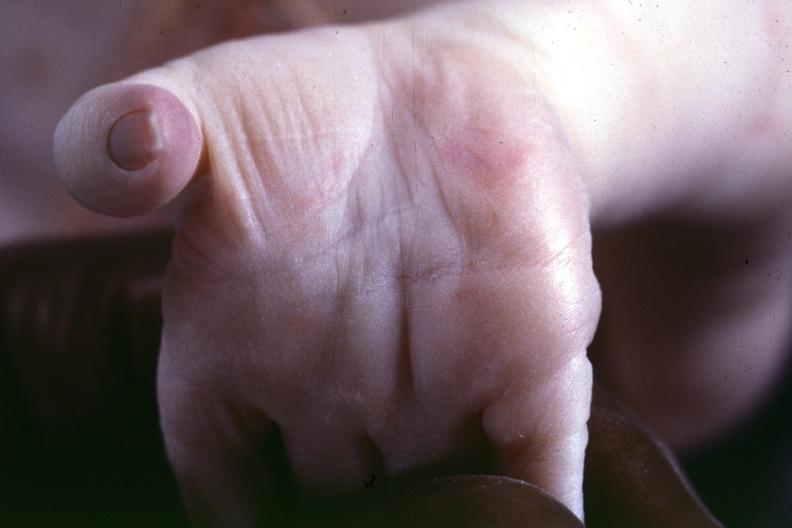what is present?
Answer the question using a single word or phrase. Hand 